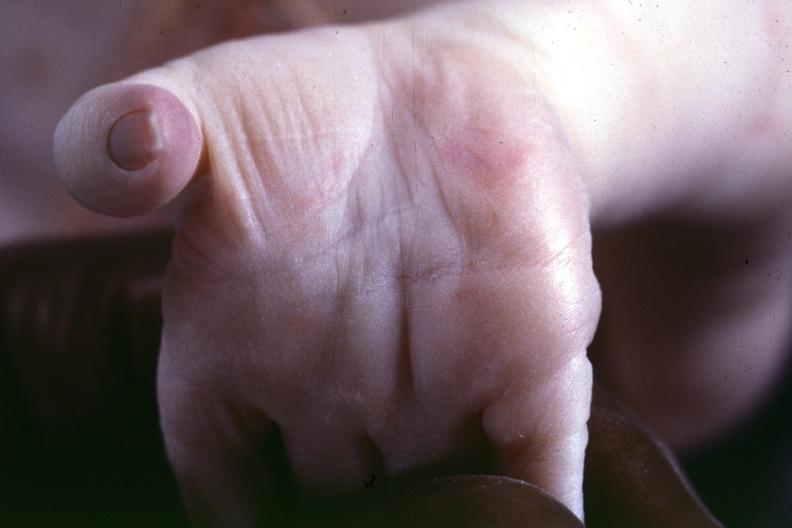what is present?
Answer the question using a single word or phrase. Hand 